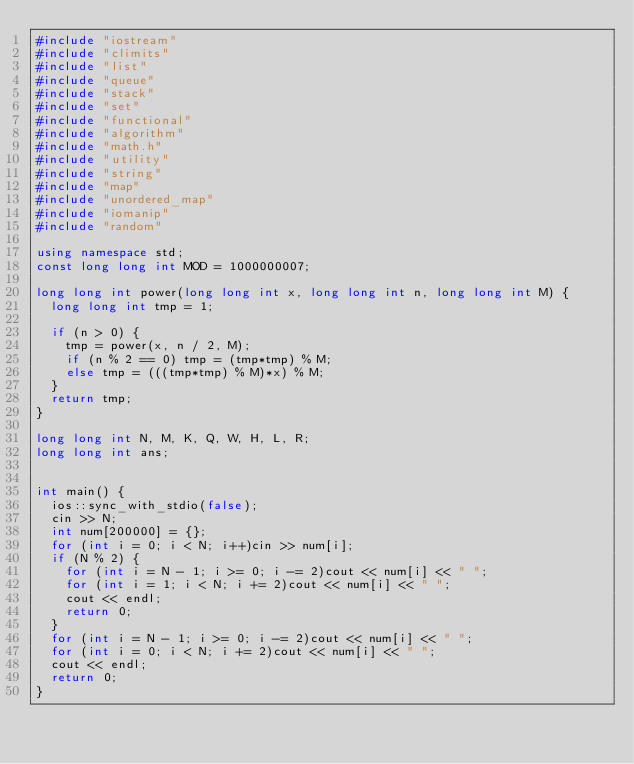Convert code to text. <code><loc_0><loc_0><loc_500><loc_500><_C++_>#include "iostream"
#include "climits"
#include "list"
#include "queue"
#include "stack"
#include "set"
#include "functional"
#include "algorithm"
#include "math.h"
#include "utility"
#include "string"
#include "map"
#include "unordered_map"
#include "iomanip"
#include "random"

using namespace std;
const long long int MOD = 1000000007;

long long int power(long long int x, long long int n, long long int M) {
	long long int tmp = 1;

	if (n > 0) {
		tmp = power(x, n / 2, M);
		if (n % 2 == 0) tmp = (tmp*tmp) % M;
		else tmp = (((tmp*tmp) % M)*x) % M;
	}
	return tmp;
}

long long int N, M, K, Q, W, H, L, R;
long long int ans;


int main() {
	ios::sync_with_stdio(false);
	cin >> N;
	int num[200000] = {};
	for (int i = 0; i < N; i++)cin >> num[i];
	if (N % 2) {
		for (int i = N - 1; i >= 0; i -= 2)cout << num[i] << " ";
		for (int i = 1; i < N; i += 2)cout << num[i] << " ";
		cout << endl;
		return 0;
	}
	for (int i = N - 1; i >= 0; i -= 2)cout << num[i] << " ";
	for (int i = 0; i < N; i += 2)cout << num[i] << " ";
	cout << endl;
	return 0;
}</code> 